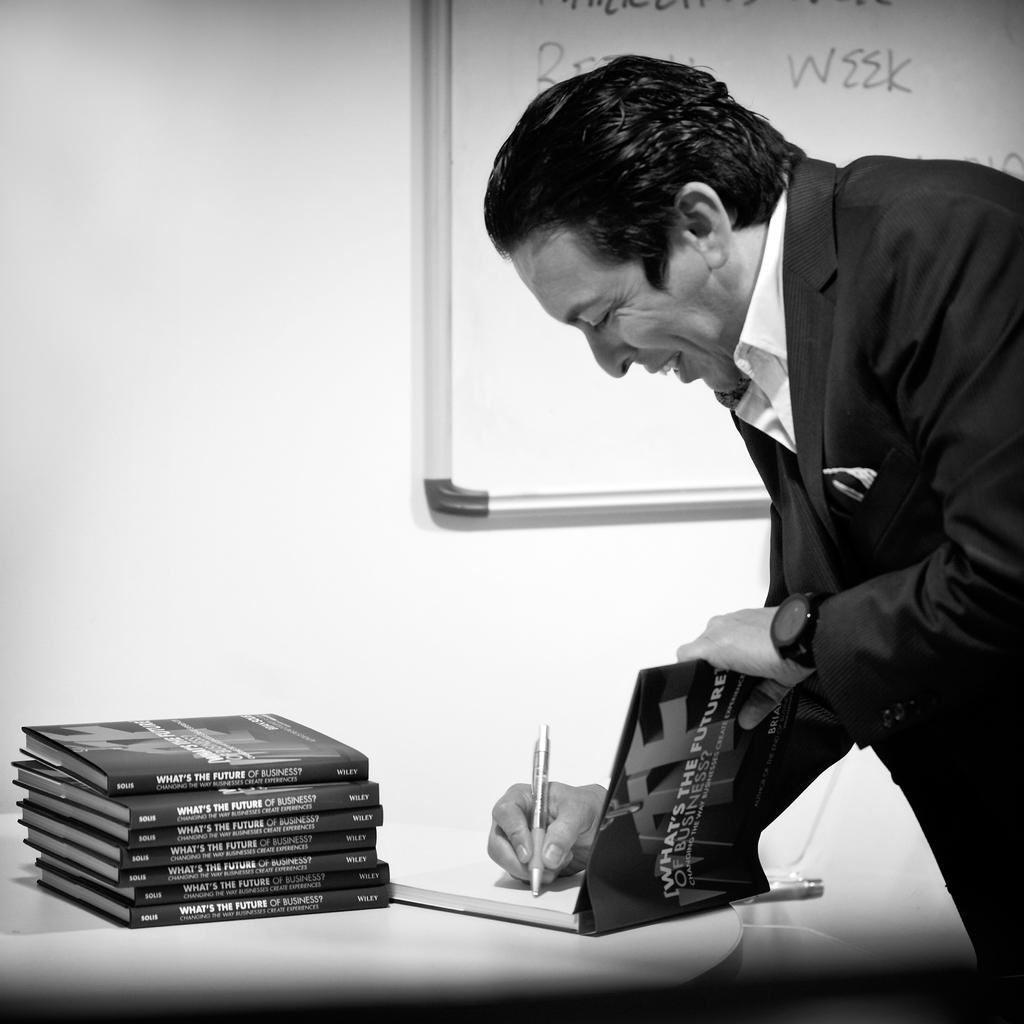<image>
Provide a brief description of the given image. A man signs a book titled What's the future of Business. 